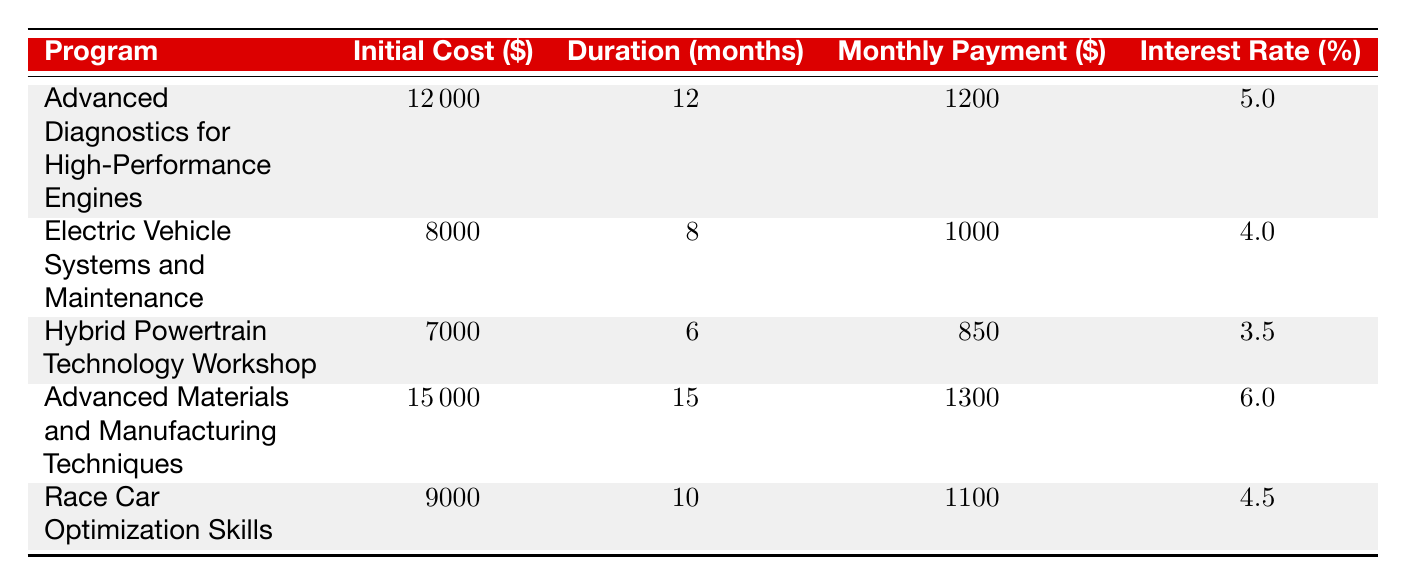What is the initial cost of the "Electric Vehicle Systems and Maintenance" program? The table shows that the "Electric Vehicle Systems and Maintenance" program has an initial cost of 8000.
Answer: 8000 How long is the duration of the "Hybrid Powertrain Technology Workshop"? According to the table, the duration of the "Hybrid Powertrain Technology Workshop" is 6 months.
Answer: 6 months Is the interest rate for "Advanced Materials and Manufacturing Techniques" higher than for "Race Car Optimization Skills"? The interest rate for "Advanced Materials and Manufacturing Techniques" is 6.0%, while for "Race Car Optimization Skills" it is 4.5%. Since 6.0% is greater than 4.5%, the statement is true.
Answer: Yes What is the total initial cost of all training programs? To find the total initial cost, we sum the initial costs from all programs: (12000 + 8000 + 7000 + 15000 + 9000) = 46000.
Answer: 46000 Which program has the highest monthly payment, and what is that amount? Upon reviewing the monthly payments for each program, "Advanced Materials and Manufacturing Techniques" has the highest monthly payment of 1300.
Answer: Advanced Materials and Manufacturing Techniques; 1300 What is the average duration of all training programs? To calculate the average duration, we add the durations: (12 + 8 + 6 + 15 + 10) = 51 months. There are 5 programs, so the average duration is 51/5 = 10.2 months.
Answer: 10.2 months Does any program have a duration of 12 months? The "Advanced Diagnostics for High-Performance Engines" program has a duration of 12 months, which confirms the answer is true.
Answer: Yes Which training program has the lowest initial cost, and who is the provider? The table indicates that the "Hybrid Powertrain Technology Workshop" has the lowest initial cost at 7000 and is provided by the "Green Car Academy".
Answer: Hybrid Powertrain Technology Workshop; Green Car Academy Is the monthly payment for "Advanced Diagnostics for High-Performance Engines" more than 1000? The monthly payment for "Advanced Diagnostics for High-Performance Engines" is 1200, which is indeed more than 1000. Therefore, the answer is true.
Answer: Yes 